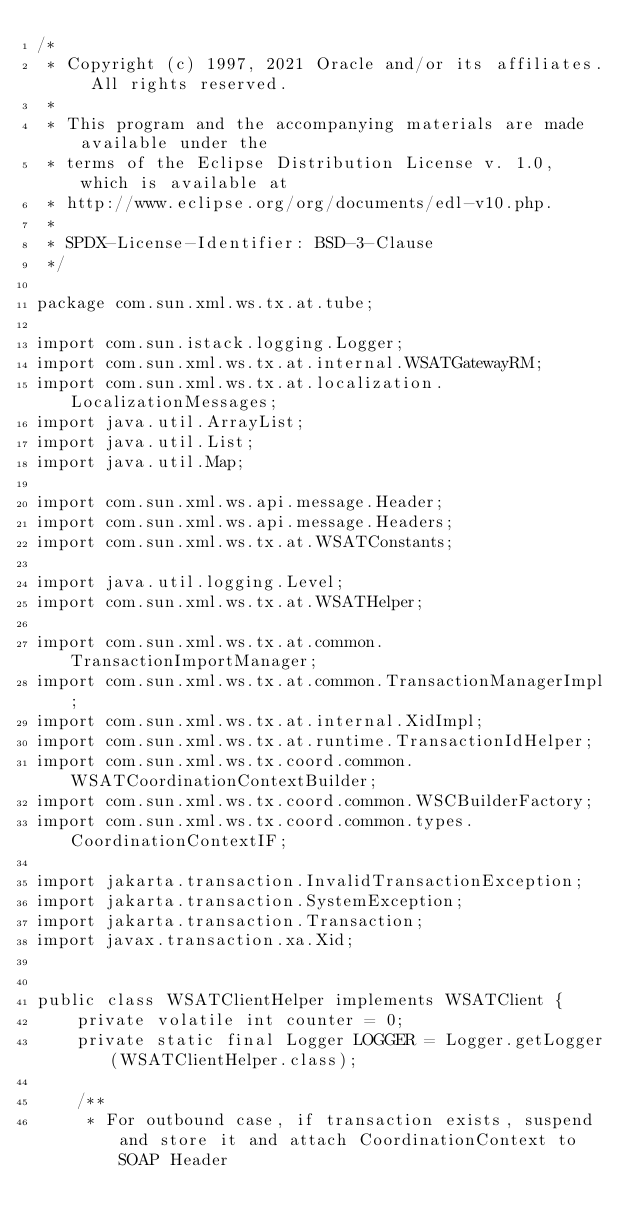<code> <loc_0><loc_0><loc_500><loc_500><_Java_>/*
 * Copyright (c) 1997, 2021 Oracle and/or its affiliates. All rights reserved.
 *
 * This program and the accompanying materials are made available under the
 * terms of the Eclipse Distribution License v. 1.0, which is available at
 * http://www.eclipse.org/org/documents/edl-v10.php.
 *
 * SPDX-License-Identifier: BSD-3-Clause
 */

package com.sun.xml.ws.tx.at.tube;

import com.sun.istack.logging.Logger;
import com.sun.xml.ws.tx.at.internal.WSATGatewayRM;
import com.sun.xml.ws.tx.at.localization.LocalizationMessages;
import java.util.ArrayList;
import java.util.List;
import java.util.Map;

import com.sun.xml.ws.api.message.Header;
import com.sun.xml.ws.api.message.Headers;
import com.sun.xml.ws.tx.at.WSATConstants;

import java.util.logging.Level;
import com.sun.xml.ws.tx.at.WSATHelper;

import com.sun.xml.ws.tx.at.common.TransactionImportManager;
import com.sun.xml.ws.tx.at.common.TransactionManagerImpl;
import com.sun.xml.ws.tx.at.internal.XidImpl;
import com.sun.xml.ws.tx.at.runtime.TransactionIdHelper;
import com.sun.xml.ws.tx.coord.common.WSATCoordinationContextBuilder;
import com.sun.xml.ws.tx.coord.common.WSCBuilderFactory;
import com.sun.xml.ws.tx.coord.common.types.CoordinationContextIF;

import jakarta.transaction.InvalidTransactionException;
import jakarta.transaction.SystemException;
import jakarta.transaction.Transaction;
import javax.transaction.xa.Xid;


public class WSATClientHelper implements WSATClient {
    private volatile int counter = 0;
    private static final Logger LOGGER = Logger.getLogger(WSATClientHelper.class);

    /**
     * For outbound case, if transaction exists, suspend and store it and attach CoordinationContext to SOAP Header</code> 